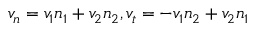<formula> <loc_0><loc_0><loc_500><loc_500>v _ { n } = v _ { 1 } n _ { 1 } + v _ { 2 } n _ { 2 } , v _ { t } = - v _ { 1 } n _ { 2 } + v _ { 2 } n _ { 1 }</formula> 